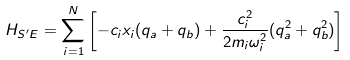<formula> <loc_0><loc_0><loc_500><loc_500>H _ { S ^ { \prime } E } = { \sum _ { i = 1 } ^ { N } \left [ - c _ { i } x _ { i } ( q _ { a } + q _ { b } ) + \frac { c _ { i } ^ { 2 } } { 2 m _ { i } \omega _ { i } ^ { 2 } } ( q _ { a } ^ { 2 } + q _ { b } ^ { 2 } ) \right ] }</formula> 